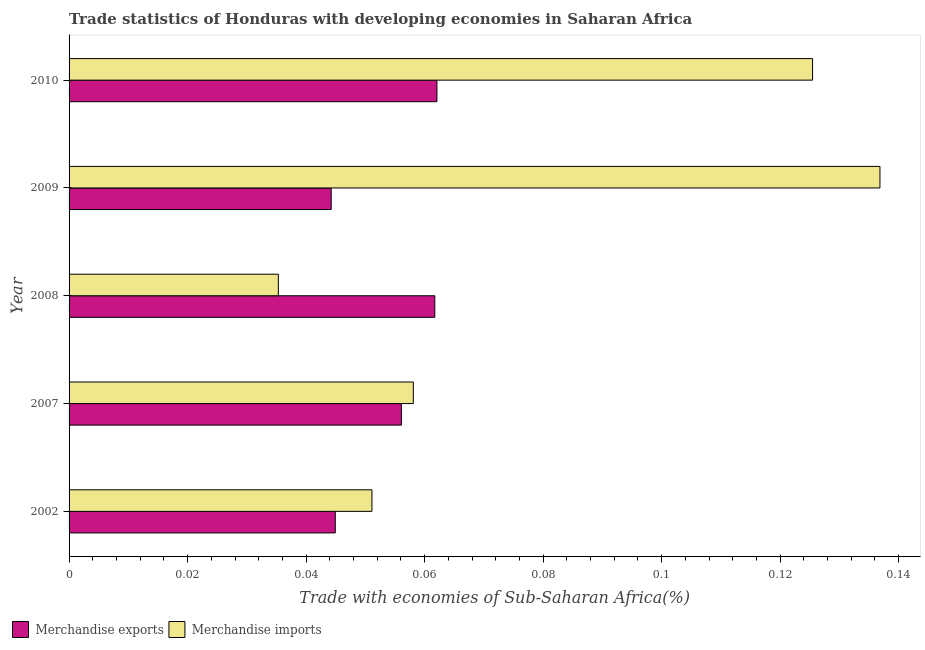How many groups of bars are there?
Make the answer very short. 5. Are the number of bars per tick equal to the number of legend labels?
Your answer should be very brief. Yes. How many bars are there on the 5th tick from the bottom?
Make the answer very short. 2. What is the label of the 5th group of bars from the top?
Your answer should be very brief. 2002. What is the merchandise imports in 2002?
Your answer should be very brief. 0.05. Across all years, what is the maximum merchandise exports?
Give a very brief answer. 0.06. Across all years, what is the minimum merchandise imports?
Offer a very short reply. 0.04. In which year was the merchandise imports maximum?
Make the answer very short. 2009. What is the total merchandise imports in the graph?
Ensure brevity in your answer.  0.41. What is the difference between the merchandise imports in 2007 and that in 2010?
Your response must be concise. -0.07. What is the difference between the merchandise exports in 2009 and the merchandise imports in 2002?
Offer a terse response. -0.01. What is the average merchandise exports per year?
Your answer should be very brief. 0.05. In the year 2002, what is the difference between the merchandise imports and merchandise exports?
Make the answer very short. 0.01. In how many years, is the merchandise exports greater than 0.068 %?
Make the answer very short. 0. What is the ratio of the merchandise imports in 2008 to that in 2010?
Ensure brevity in your answer.  0.28. Is the difference between the merchandise imports in 2002 and 2009 greater than the difference between the merchandise exports in 2002 and 2009?
Your response must be concise. No. What is the difference between the highest and the second highest merchandise imports?
Offer a very short reply. 0.01. How many years are there in the graph?
Ensure brevity in your answer.  5. What is the difference between two consecutive major ticks on the X-axis?
Provide a short and direct response. 0.02. Does the graph contain any zero values?
Give a very brief answer. No. What is the title of the graph?
Offer a terse response. Trade statistics of Honduras with developing economies in Saharan Africa. Does "RDB concessional" appear as one of the legend labels in the graph?
Your answer should be compact. No. What is the label or title of the X-axis?
Your answer should be compact. Trade with economies of Sub-Saharan Africa(%). What is the Trade with economies of Sub-Saharan Africa(%) of Merchandise exports in 2002?
Give a very brief answer. 0.04. What is the Trade with economies of Sub-Saharan Africa(%) of Merchandise imports in 2002?
Offer a terse response. 0.05. What is the Trade with economies of Sub-Saharan Africa(%) in Merchandise exports in 2007?
Keep it short and to the point. 0.06. What is the Trade with economies of Sub-Saharan Africa(%) in Merchandise imports in 2007?
Offer a very short reply. 0.06. What is the Trade with economies of Sub-Saharan Africa(%) in Merchandise exports in 2008?
Your answer should be compact. 0.06. What is the Trade with economies of Sub-Saharan Africa(%) in Merchandise imports in 2008?
Offer a terse response. 0.04. What is the Trade with economies of Sub-Saharan Africa(%) of Merchandise exports in 2009?
Your answer should be very brief. 0.04. What is the Trade with economies of Sub-Saharan Africa(%) of Merchandise imports in 2009?
Your answer should be very brief. 0.14. What is the Trade with economies of Sub-Saharan Africa(%) in Merchandise exports in 2010?
Your response must be concise. 0.06. What is the Trade with economies of Sub-Saharan Africa(%) of Merchandise imports in 2010?
Offer a terse response. 0.13. Across all years, what is the maximum Trade with economies of Sub-Saharan Africa(%) in Merchandise exports?
Your answer should be compact. 0.06. Across all years, what is the maximum Trade with economies of Sub-Saharan Africa(%) of Merchandise imports?
Offer a very short reply. 0.14. Across all years, what is the minimum Trade with economies of Sub-Saharan Africa(%) in Merchandise exports?
Keep it short and to the point. 0.04. Across all years, what is the minimum Trade with economies of Sub-Saharan Africa(%) in Merchandise imports?
Keep it short and to the point. 0.04. What is the total Trade with economies of Sub-Saharan Africa(%) in Merchandise exports in the graph?
Make the answer very short. 0.27. What is the total Trade with economies of Sub-Saharan Africa(%) in Merchandise imports in the graph?
Provide a succinct answer. 0.41. What is the difference between the Trade with economies of Sub-Saharan Africa(%) of Merchandise exports in 2002 and that in 2007?
Give a very brief answer. -0.01. What is the difference between the Trade with economies of Sub-Saharan Africa(%) in Merchandise imports in 2002 and that in 2007?
Keep it short and to the point. -0.01. What is the difference between the Trade with economies of Sub-Saharan Africa(%) of Merchandise exports in 2002 and that in 2008?
Keep it short and to the point. -0.02. What is the difference between the Trade with economies of Sub-Saharan Africa(%) of Merchandise imports in 2002 and that in 2008?
Make the answer very short. 0.02. What is the difference between the Trade with economies of Sub-Saharan Africa(%) of Merchandise exports in 2002 and that in 2009?
Give a very brief answer. 0. What is the difference between the Trade with economies of Sub-Saharan Africa(%) in Merchandise imports in 2002 and that in 2009?
Your response must be concise. -0.09. What is the difference between the Trade with economies of Sub-Saharan Africa(%) in Merchandise exports in 2002 and that in 2010?
Offer a very short reply. -0.02. What is the difference between the Trade with economies of Sub-Saharan Africa(%) in Merchandise imports in 2002 and that in 2010?
Give a very brief answer. -0.07. What is the difference between the Trade with economies of Sub-Saharan Africa(%) of Merchandise exports in 2007 and that in 2008?
Your answer should be very brief. -0.01. What is the difference between the Trade with economies of Sub-Saharan Africa(%) in Merchandise imports in 2007 and that in 2008?
Your answer should be compact. 0.02. What is the difference between the Trade with economies of Sub-Saharan Africa(%) of Merchandise exports in 2007 and that in 2009?
Your response must be concise. 0.01. What is the difference between the Trade with economies of Sub-Saharan Africa(%) in Merchandise imports in 2007 and that in 2009?
Your answer should be very brief. -0.08. What is the difference between the Trade with economies of Sub-Saharan Africa(%) of Merchandise exports in 2007 and that in 2010?
Give a very brief answer. -0.01. What is the difference between the Trade with economies of Sub-Saharan Africa(%) of Merchandise imports in 2007 and that in 2010?
Your response must be concise. -0.07. What is the difference between the Trade with economies of Sub-Saharan Africa(%) of Merchandise exports in 2008 and that in 2009?
Give a very brief answer. 0.02. What is the difference between the Trade with economies of Sub-Saharan Africa(%) of Merchandise imports in 2008 and that in 2009?
Provide a succinct answer. -0.1. What is the difference between the Trade with economies of Sub-Saharan Africa(%) of Merchandise exports in 2008 and that in 2010?
Your answer should be very brief. -0. What is the difference between the Trade with economies of Sub-Saharan Africa(%) of Merchandise imports in 2008 and that in 2010?
Offer a very short reply. -0.09. What is the difference between the Trade with economies of Sub-Saharan Africa(%) in Merchandise exports in 2009 and that in 2010?
Offer a very short reply. -0.02. What is the difference between the Trade with economies of Sub-Saharan Africa(%) in Merchandise imports in 2009 and that in 2010?
Give a very brief answer. 0.01. What is the difference between the Trade with economies of Sub-Saharan Africa(%) in Merchandise exports in 2002 and the Trade with economies of Sub-Saharan Africa(%) in Merchandise imports in 2007?
Your response must be concise. -0.01. What is the difference between the Trade with economies of Sub-Saharan Africa(%) in Merchandise exports in 2002 and the Trade with economies of Sub-Saharan Africa(%) in Merchandise imports in 2008?
Your response must be concise. 0.01. What is the difference between the Trade with economies of Sub-Saharan Africa(%) of Merchandise exports in 2002 and the Trade with economies of Sub-Saharan Africa(%) of Merchandise imports in 2009?
Provide a succinct answer. -0.09. What is the difference between the Trade with economies of Sub-Saharan Africa(%) in Merchandise exports in 2002 and the Trade with economies of Sub-Saharan Africa(%) in Merchandise imports in 2010?
Give a very brief answer. -0.08. What is the difference between the Trade with economies of Sub-Saharan Africa(%) of Merchandise exports in 2007 and the Trade with economies of Sub-Saharan Africa(%) of Merchandise imports in 2008?
Provide a succinct answer. 0.02. What is the difference between the Trade with economies of Sub-Saharan Africa(%) in Merchandise exports in 2007 and the Trade with economies of Sub-Saharan Africa(%) in Merchandise imports in 2009?
Offer a terse response. -0.08. What is the difference between the Trade with economies of Sub-Saharan Africa(%) in Merchandise exports in 2007 and the Trade with economies of Sub-Saharan Africa(%) in Merchandise imports in 2010?
Offer a terse response. -0.07. What is the difference between the Trade with economies of Sub-Saharan Africa(%) of Merchandise exports in 2008 and the Trade with economies of Sub-Saharan Africa(%) of Merchandise imports in 2009?
Your answer should be compact. -0.08. What is the difference between the Trade with economies of Sub-Saharan Africa(%) of Merchandise exports in 2008 and the Trade with economies of Sub-Saharan Africa(%) of Merchandise imports in 2010?
Offer a terse response. -0.06. What is the difference between the Trade with economies of Sub-Saharan Africa(%) in Merchandise exports in 2009 and the Trade with economies of Sub-Saharan Africa(%) in Merchandise imports in 2010?
Your answer should be compact. -0.08. What is the average Trade with economies of Sub-Saharan Africa(%) of Merchandise exports per year?
Keep it short and to the point. 0.05. What is the average Trade with economies of Sub-Saharan Africa(%) in Merchandise imports per year?
Make the answer very short. 0.08. In the year 2002, what is the difference between the Trade with economies of Sub-Saharan Africa(%) in Merchandise exports and Trade with economies of Sub-Saharan Africa(%) in Merchandise imports?
Keep it short and to the point. -0.01. In the year 2007, what is the difference between the Trade with economies of Sub-Saharan Africa(%) of Merchandise exports and Trade with economies of Sub-Saharan Africa(%) of Merchandise imports?
Keep it short and to the point. -0. In the year 2008, what is the difference between the Trade with economies of Sub-Saharan Africa(%) in Merchandise exports and Trade with economies of Sub-Saharan Africa(%) in Merchandise imports?
Your response must be concise. 0.03. In the year 2009, what is the difference between the Trade with economies of Sub-Saharan Africa(%) of Merchandise exports and Trade with economies of Sub-Saharan Africa(%) of Merchandise imports?
Provide a succinct answer. -0.09. In the year 2010, what is the difference between the Trade with economies of Sub-Saharan Africa(%) of Merchandise exports and Trade with economies of Sub-Saharan Africa(%) of Merchandise imports?
Offer a very short reply. -0.06. What is the ratio of the Trade with economies of Sub-Saharan Africa(%) in Merchandise exports in 2002 to that in 2007?
Your answer should be compact. 0.8. What is the ratio of the Trade with economies of Sub-Saharan Africa(%) in Merchandise imports in 2002 to that in 2007?
Offer a very short reply. 0.88. What is the ratio of the Trade with economies of Sub-Saharan Africa(%) in Merchandise exports in 2002 to that in 2008?
Your answer should be compact. 0.73. What is the ratio of the Trade with economies of Sub-Saharan Africa(%) of Merchandise imports in 2002 to that in 2008?
Give a very brief answer. 1.45. What is the ratio of the Trade with economies of Sub-Saharan Africa(%) in Merchandise exports in 2002 to that in 2009?
Keep it short and to the point. 1.02. What is the ratio of the Trade with economies of Sub-Saharan Africa(%) in Merchandise imports in 2002 to that in 2009?
Offer a very short reply. 0.37. What is the ratio of the Trade with economies of Sub-Saharan Africa(%) in Merchandise exports in 2002 to that in 2010?
Ensure brevity in your answer.  0.72. What is the ratio of the Trade with economies of Sub-Saharan Africa(%) in Merchandise imports in 2002 to that in 2010?
Offer a terse response. 0.41. What is the ratio of the Trade with economies of Sub-Saharan Africa(%) in Merchandise exports in 2007 to that in 2008?
Ensure brevity in your answer.  0.91. What is the ratio of the Trade with economies of Sub-Saharan Africa(%) of Merchandise imports in 2007 to that in 2008?
Your answer should be very brief. 1.65. What is the ratio of the Trade with economies of Sub-Saharan Africa(%) in Merchandise exports in 2007 to that in 2009?
Give a very brief answer. 1.27. What is the ratio of the Trade with economies of Sub-Saharan Africa(%) in Merchandise imports in 2007 to that in 2009?
Your answer should be very brief. 0.42. What is the ratio of the Trade with economies of Sub-Saharan Africa(%) in Merchandise exports in 2007 to that in 2010?
Keep it short and to the point. 0.9. What is the ratio of the Trade with economies of Sub-Saharan Africa(%) of Merchandise imports in 2007 to that in 2010?
Your answer should be very brief. 0.46. What is the ratio of the Trade with economies of Sub-Saharan Africa(%) in Merchandise exports in 2008 to that in 2009?
Keep it short and to the point. 1.4. What is the ratio of the Trade with economies of Sub-Saharan Africa(%) in Merchandise imports in 2008 to that in 2009?
Make the answer very short. 0.26. What is the ratio of the Trade with economies of Sub-Saharan Africa(%) in Merchandise imports in 2008 to that in 2010?
Provide a succinct answer. 0.28. What is the ratio of the Trade with economies of Sub-Saharan Africa(%) of Merchandise exports in 2009 to that in 2010?
Ensure brevity in your answer.  0.71. What is the ratio of the Trade with economies of Sub-Saharan Africa(%) in Merchandise imports in 2009 to that in 2010?
Your answer should be compact. 1.09. What is the difference between the highest and the second highest Trade with economies of Sub-Saharan Africa(%) of Merchandise imports?
Keep it short and to the point. 0.01. What is the difference between the highest and the lowest Trade with economies of Sub-Saharan Africa(%) of Merchandise exports?
Your answer should be very brief. 0.02. What is the difference between the highest and the lowest Trade with economies of Sub-Saharan Africa(%) in Merchandise imports?
Ensure brevity in your answer.  0.1. 